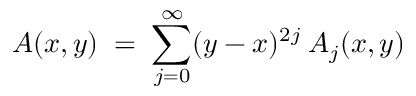<formula> <loc_0><loc_0><loc_500><loc_500>A ( x , y ) \, = \, \sum _ { j = 0 } ^ { \infty } ( y - x ) ^ { 2 j } \, A _ { j } ( x , y )</formula> 